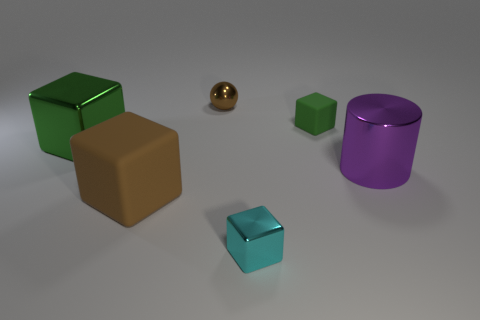How many cubes are metal things or brown metal things?
Keep it short and to the point. 2. There is a big metallic thing that is behind the large metal cylinder; what number of big objects are on the right side of it?
Make the answer very short. 2. Does the ball have the same material as the large purple cylinder?
Offer a very short reply. Yes. The metallic block that is the same color as the small rubber block is what size?
Offer a terse response. Large. Are there any other tiny blocks that have the same material as the small cyan block?
Provide a succinct answer. No. The rubber thing in front of the green thing that is in front of the block behind the large green metallic block is what color?
Ensure brevity in your answer.  Brown. How many brown things are either rubber balls or tiny shiny balls?
Your answer should be very brief. 1. How many large matte objects have the same shape as the large purple metallic object?
Offer a terse response. 0. There is a purple metal object that is the same size as the brown rubber cube; what shape is it?
Your response must be concise. Cylinder. There is a large purple metallic thing; are there any shiny blocks in front of it?
Make the answer very short. Yes. 